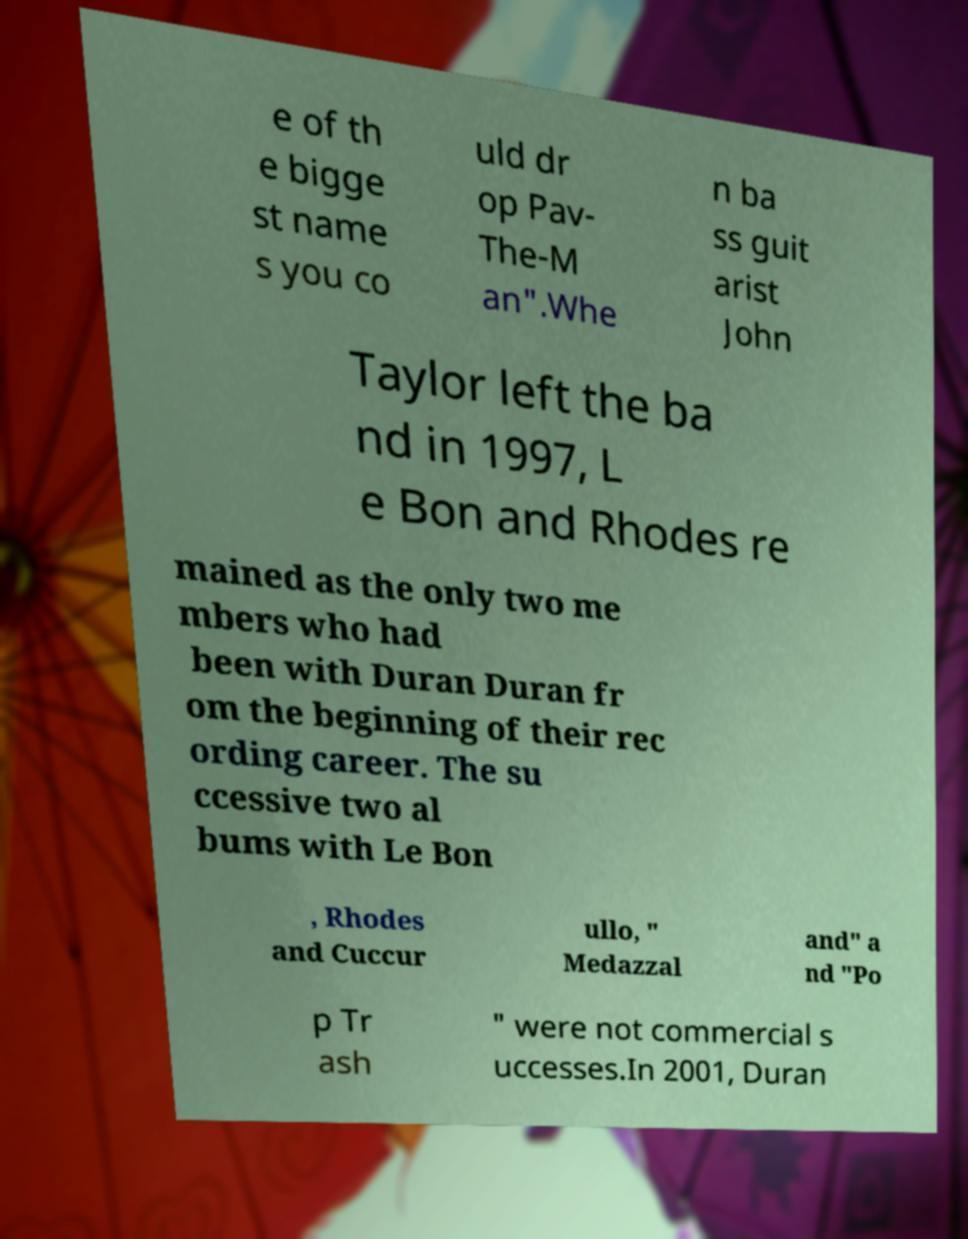Could you assist in decoding the text presented in this image and type it out clearly? e of th e bigge st name s you co uld dr op Pav- The-M an".Whe n ba ss guit arist John Taylor left the ba nd in 1997, L e Bon and Rhodes re mained as the only two me mbers who had been with Duran Duran fr om the beginning of their rec ording career. The su ccessive two al bums with Le Bon , Rhodes and Cuccur ullo, " Medazzal and" a nd "Po p Tr ash " were not commercial s uccesses.In 2001, Duran 